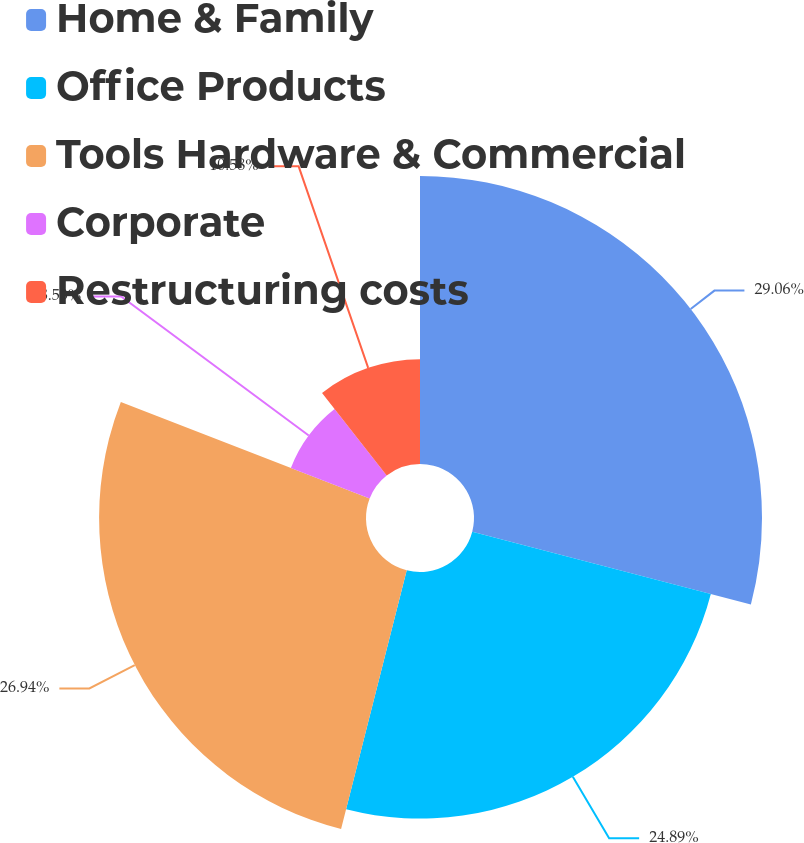Convert chart to OTSL. <chart><loc_0><loc_0><loc_500><loc_500><pie_chart><fcel>Home & Family<fcel>Office Products<fcel>Tools Hardware & Commercial<fcel>Corporate<fcel>Restructuring costs<nl><fcel>29.07%<fcel>24.89%<fcel>26.94%<fcel>8.53%<fcel>10.58%<nl></chart> 